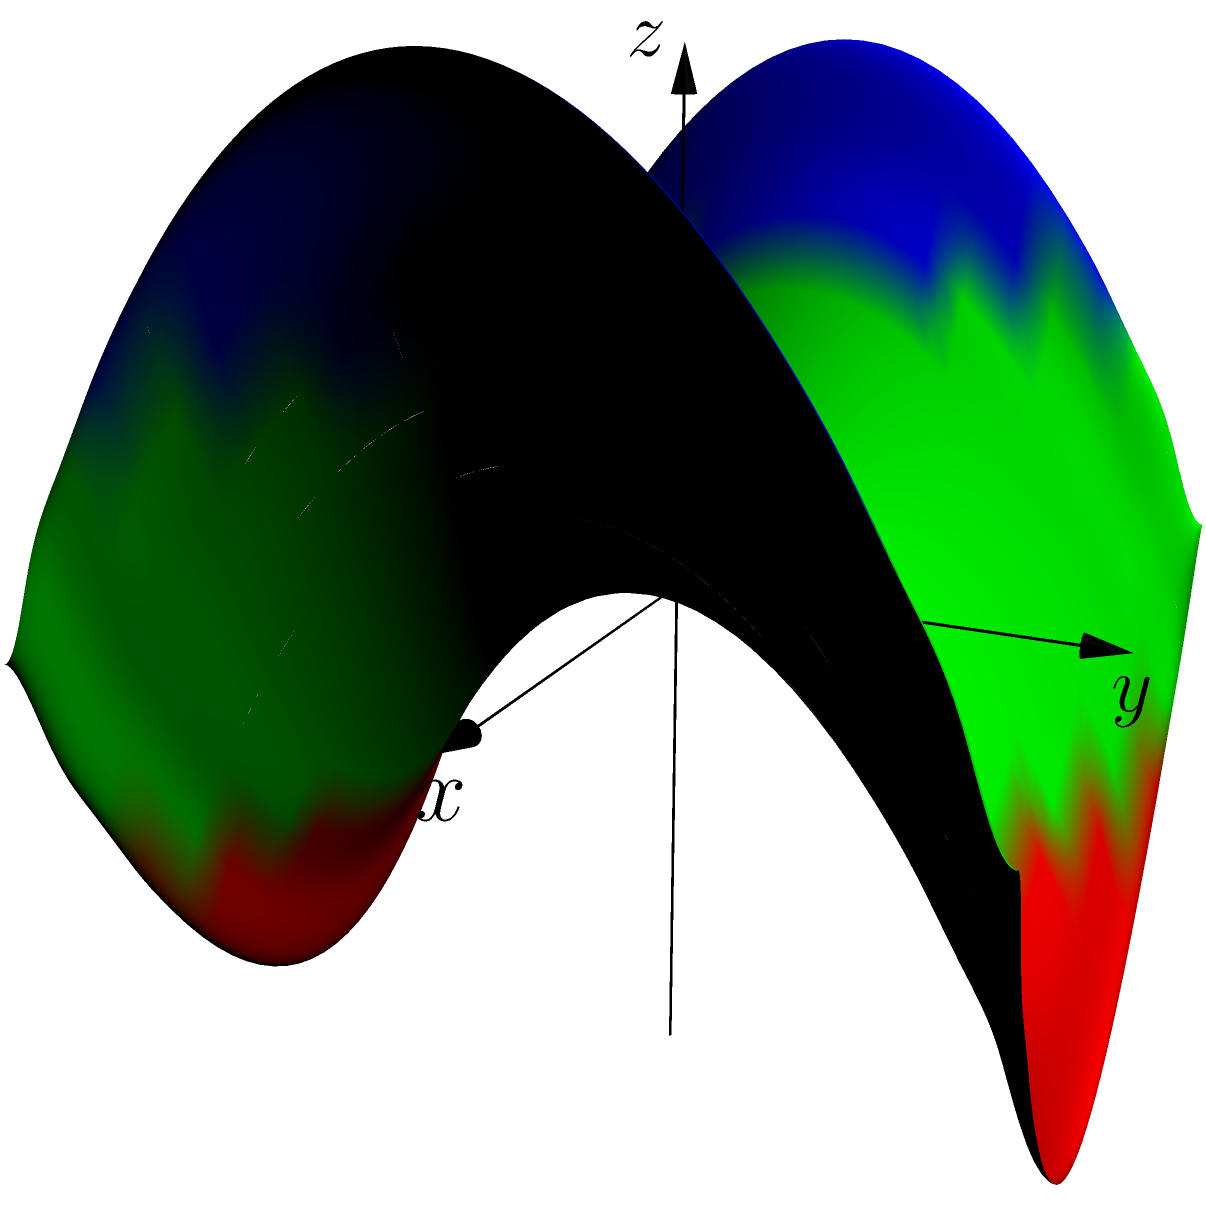In your days at Zeda Computers, you often worked with 3D modeling. Recall the shape of a hyperbolic paraboloid, which is represented by the equation $z = \frac{x^2 - y^2}{4}$. What geometric property does this surface exhibit that distinguishes it from a regular paraboloid? Let's analyze this step-by-step:

1) First, recall that a hyperbolic paraboloid is a doubly ruled surface, meaning it can be generated by two families of straight lines.

2) Looking at the equation $z = \frac{x^2 - y^2}{4}$, we can rewrite it as:

   $4z = x^2 - y^2$

3) This can be factored as:

   $(2z+y)(2z-y) = x^2$

4) For any fixed value of $z$, this equation represents a hyperbola in the $x$-$y$ plane.

5) If we fix $x$ instead, we get:

   $y^2 - 4z = -x^2$

   Which represents a parabola in the $y$-$z$ plane.

6) This means that any horizontal slice of the surface (constant $z$) is a hyperbola, while any vertical slice parallel to the $y$-$z$ plane (constant $x$) is a parabola.

7) The key distinguishing feature is that this surface has a saddle point at the origin (0,0,0), where it curves upward in one direction and downward in the perpendicular direction.

8) This is different from a regular paraboloid (like $z = x^2 + y^2$), which curves the same way in all directions from its vertex.

Therefore, the key geometric property that distinguishes a hyperbolic paraboloid from a regular paraboloid is its saddle shape, with curvature in opposite directions.
Answer: Saddle point with opposite curvatures 